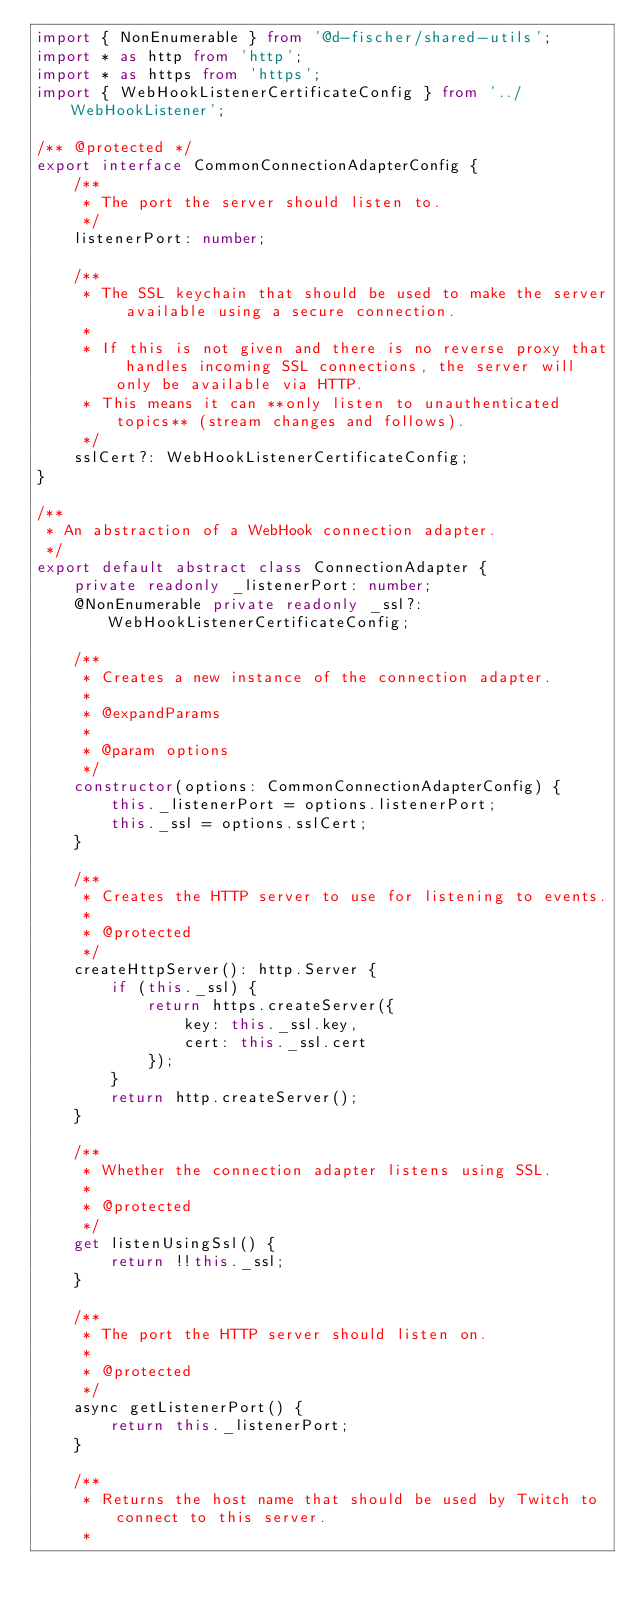Convert code to text. <code><loc_0><loc_0><loc_500><loc_500><_TypeScript_>import { NonEnumerable } from '@d-fischer/shared-utils';
import * as http from 'http';
import * as https from 'https';
import { WebHookListenerCertificateConfig } from '../WebHookListener';

/** @protected */
export interface CommonConnectionAdapterConfig {
	/**
	 * The port the server should listen to.
	 */
	listenerPort: number;

	/**
	 * The SSL keychain that should be used to make the server available using a secure connection.
	 *
	 * If this is not given and there is no reverse proxy that handles incoming SSL connections, the server will only be available via HTTP.
	 * This means it can **only listen to unauthenticated topics** (stream changes and follows).
	 */
	sslCert?: WebHookListenerCertificateConfig;
}

/**
 * An abstraction of a WebHook connection adapter.
 */
export default abstract class ConnectionAdapter {
	private readonly _listenerPort: number;
	@NonEnumerable private readonly _ssl?: WebHookListenerCertificateConfig;

	/**
	 * Creates a new instance of the connection adapter.
	 *
	 * @expandParams
	 *
	 * @param options
	 */
	constructor(options: CommonConnectionAdapterConfig) {
		this._listenerPort = options.listenerPort;
		this._ssl = options.sslCert;
	}

	/**
	 * Creates the HTTP server to use for listening to events.
	 *
	 * @protected
	 */
	createHttpServer(): http.Server {
		if (this._ssl) {
			return https.createServer({
				key: this._ssl.key,
				cert: this._ssl.cert
			});
		}
		return http.createServer();
	}

	/**
	 * Whether the connection adapter listens using SSL.
	 *
	 * @protected
	 */
	get listenUsingSsl() {
		return !!this._ssl;
	}

	/**
	 * The port the HTTP server should listen on.
	 *
	 * @protected
	 */
	async getListenerPort() {
		return this._listenerPort;
	}

	/**
	 * Returns the host name that should be used by Twitch to connect to this server.
	 *</code> 